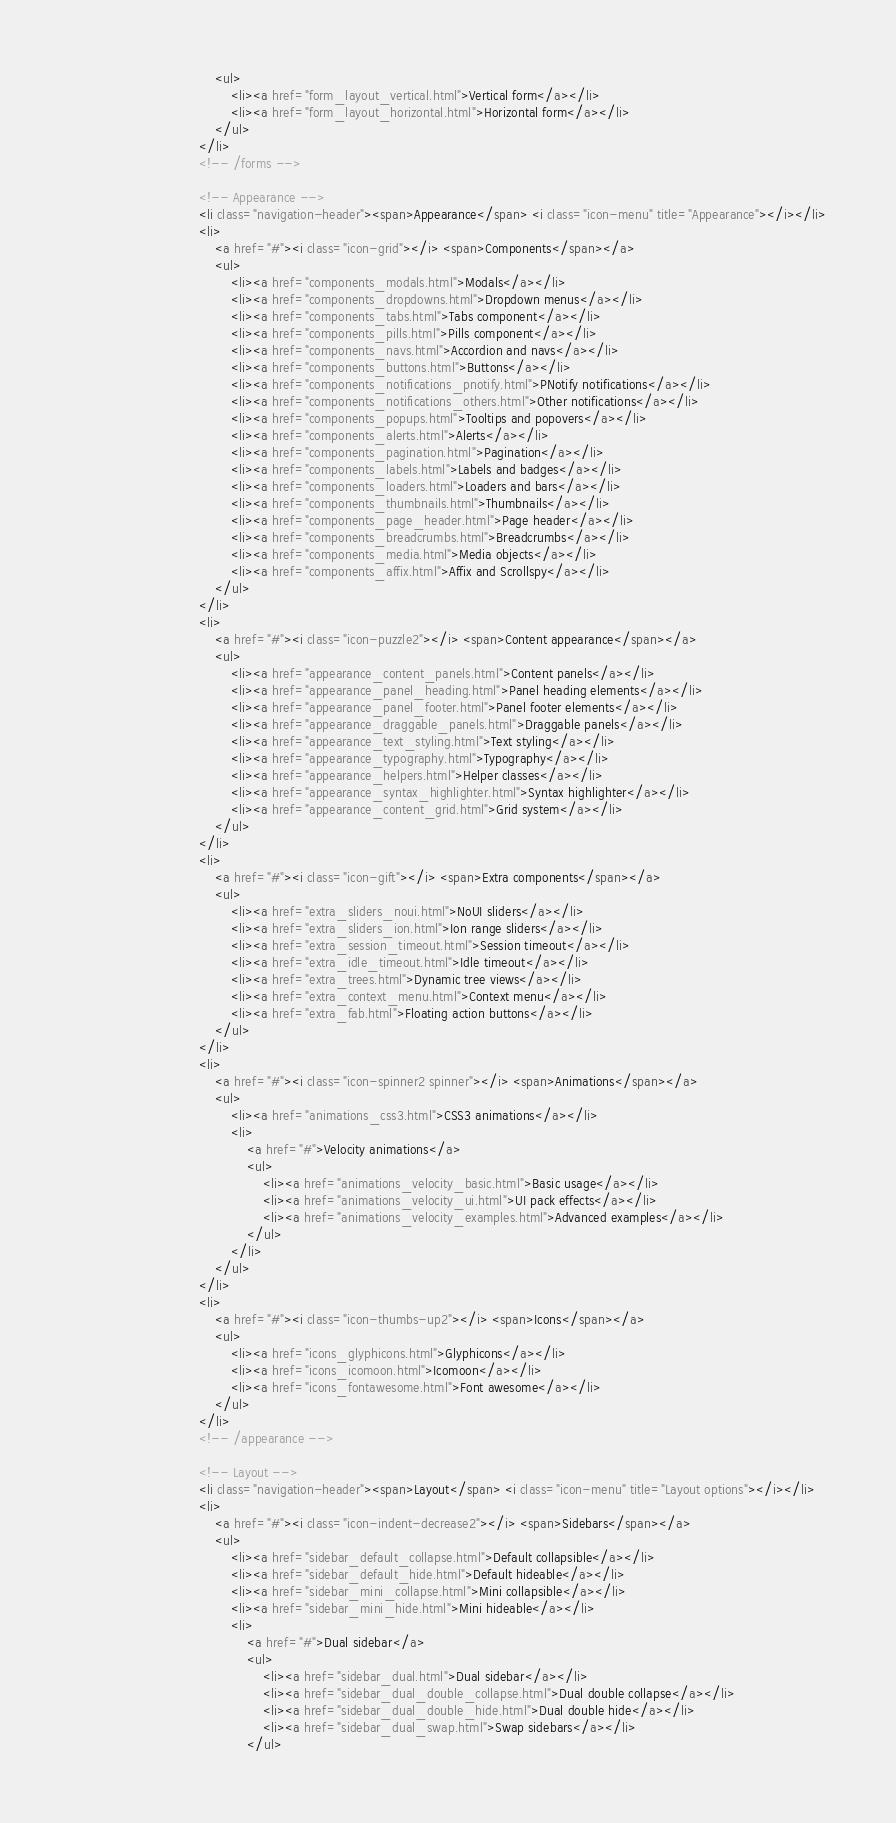Convert code to text. <code><loc_0><loc_0><loc_500><loc_500><_HTML_>									<ul>
										<li><a href="form_layout_vertical.html">Vertical form</a></li>
										<li><a href="form_layout_horizontal.html">Horizontal form</a></li>
									</ul>
								</li>
								<!-- /forms -->

								<!-- Appearance -->
								<li class="navigation-header"><span>Appearance</span> <i class="icon-menu" title="Appearance"></i></li>
								<li>
									<a href="#"><i class="icon-grid"></i> <span>Components</span></a>
									<ul>
										<li><a href="components_modals.html">Modals</a></li>
										<li><a href="components_dropdowns.html">Dropdown menus</a></li>
										<li><a href="components_tabs.html">Tabs component</a></li>
										<li><a href="components_pills.html">Pills component</a></li>
										<li><a href="components_navs.html">Accordion and navs</a></li>
										<li><a href="components_buttons.html">Buttons</a></li>
										<li><a href="components_notifications_pnotify.html">PNotify notifications</a></li>
										<li><a href="components_notifications_others.html">Other notifications</a></li>
										<li><a href="components_popups.html">Tooltips and popovers</a></li>
										<li><a href="components_alerts.html">Alerts</a></li>
										<li><a href="components_pagination.html">Pagination</a></li>
										<li><a href="components_labels.html">Labels and badges</a></li>
										<li><a href="components_loaders.html">Loaders and bars</a></li>
										<li><a href="components_thumbnails.html">Thumbnails</a></li>
										<li><a href="components_page_header.html">Page header</a></li>
										<li><a href="components_breadcrumbs.html">Breadcrumbs</a></li>
										<li><a href="components_media.html">Media objects</a></li>
										<li><a href="components_affix.html">Affix and Scrollspy</a></li>
									</ul>
								</li>
								<li>
									<a href="#"><i class="icon-puzzle2"></i> <span>Content appearance</span></a>
									<ul>
										<li><a href="appearance_content_panels.html">Content panels</a></li>
										<li><a href="appearance_panel_heading.html">Panel heading elements</a></li>
										<li><a href="appearance_panel_footer.html">Panel footer elements</a></li>
										<li><a href="appearance_draggable_panels.html">Draggable panels</a></li>
										<li><a href="appearance_text_styling.html">Text styling</a></li>
										<li><a href="appearance_typography.html">Typography</a></li>
										<li><a href="appearance_helpers.html">Helper classes</a></li>
										<li><a href="appearance_syntax_highlighter.html">Syntax highlighter</a></li>
										<li><a href="appearance_content_grid.html">Grid system</a></li>
									</ul>
								</li>
								<li>
									<a href="#"><i class="icon-gift"></i> <span>Extra components</span></a>
									<ul>
										<li><a href="extra_sliders_noui.html">NoUI sliders</a></li>
										<li><a href="extra_sliders_ion.html">Ion range sliders</a></li>
										<li><a href="extra_session_timeout.html">Session timeout</a></li>
										<li><a href="extra_idle_timeout.html">Idle timeout</a></li>
										<li><a href="extra_trees.html">Dynamic tree views</a></li>
										<li><a href="extra_context_menu.html">Context menu</a></li>
										<li><a href="extra_fab.html">Floating action buttons</a></li>
									</ul>
								</li>
								<li>
									<a href="#"><i class="icon-spinner2 spinner"></i> <span>Animations</span></a>
									<ul>
										<li><a href="animations_css3.html">CSS3 animations</a></li>
										<li>
											<a href="#">Velocity animations</a>
											<ul>
												<li><a href="animations_velocity_basic.html">Basic usage</a></li>
												<li><a href="animations_velocity_ui.html">UI pack effects</a></li>
												<li><a href="animations_velocity_examples.html">Advanced examples</a></li>
											</ul>
										</li>
									</ul>
								</li>
								<li>
									<a href="#"><i class="icon-thumbs-up2"></i> <span>Icons</span></a>
									<ul>
										<li><a href="icons_glyphicons.html">Glyphicons</a></li>
										<li><a href="icons_icomoon.html">Icomoon</a></li>
										<li><a href="icons_fontawesome.html">Font awesome</a></li>
									</ul>
								</li>
								<!-- /appearance -->

								<!-- Layout -->
								<li class="navigation-header"><span>Layout</span> <i class="icon-menu" title="Layout options"></i></li>
								<li>
									<a href="#"><i class="icon-indent-decrease2"></i> <span>Sidebars</span></a>
									<ul>
										<li><a href="sidebar_default_collapse.html">Default collapsible</a></li>
										<li><a href="sidebar_default_hide.html">Default hideable</a></li>
										<li><a href="sidebar_mini_collapse.html">Mini collapsible</a></li>
										<li><a href="sidebar_mini_hide.html">Mini hideable</a></li>
										<li>
											<a href="#">Dual sidebar</a>
											<ul>
												<li><a href="sidebar_dual.html">Dual sidebar</a></li>
												<li><a href="sidebar_dual_double_collapse.html">Dual double collapse</a></li>
												<li><a href="sidebar_dual_double_hide.html">Dual double hide</a></li>
												<li><a href="sidebar_dual_swap.html">Swap sidebars</a></li>
											</ul></code> 